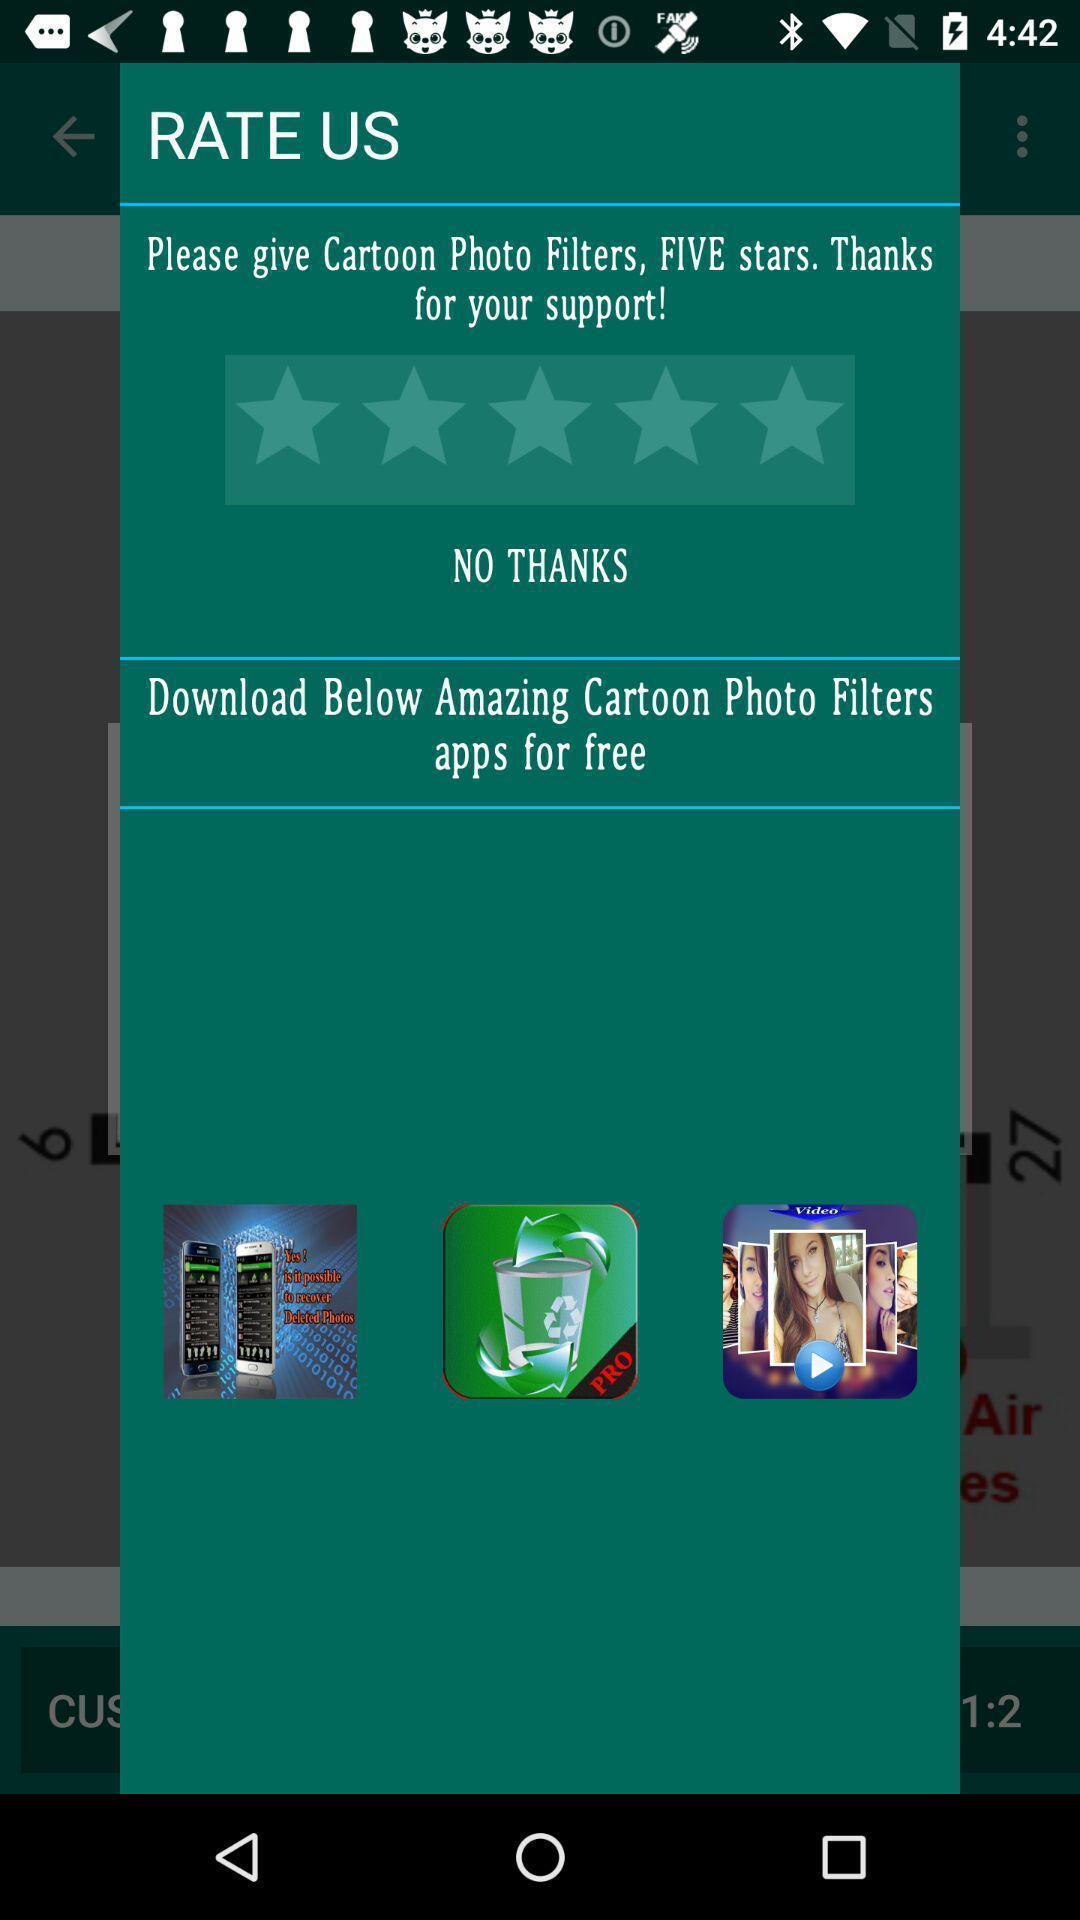Explain the elements present in this screenshot. Pop-up to rate a particular filter app. 